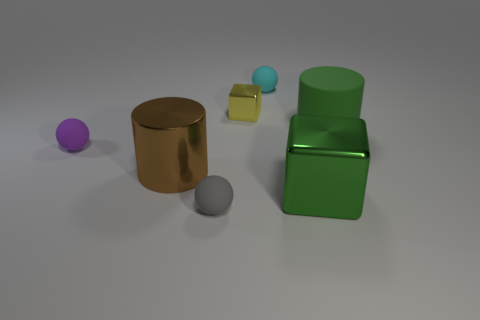What is the shape of the metallic object that is both on the right side of the small gray matte thing and in front of the small metal thing? The shape of the metallic object you are referring to appears to be a cube. It's positioned to the right of the gray sphere and in front of the cylindrical bronze object. 